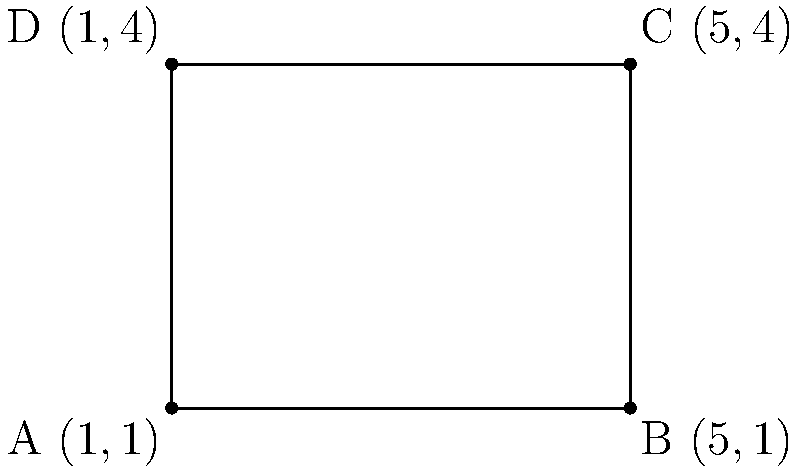Your tech-savvy family member is explaining a simple application of coordinate geometry. They've drawn a rectangle on a graph and marked its corners with coordinates. The corners are labeled A(1,1), B(5,1), C(5,4), and D(1,4). How would you calculate the area of this rectangle using these coordinates? To find the area of the rectangle, we can follow these simple steps:

1. Find the length of the rectangle:
   - The length is the distance between points A and B (or D and C)
   - Length = $5 - 1 = 4$ units

2. Find the width of the rectangle:
   - The width is the distance between points A and D (or B and C)
   - Width = $4 - 1 = 3$ units

3. Calculate the area:
   - Area of a rectangle = length × width
   - Area = $4 × 3 = 12$ square units

Thus, we can determine the area of the rectangle by simply multiplying the difference in x-coordinates (for length) by the difference in y-coordinates (for width).
Answer: 12 square units 